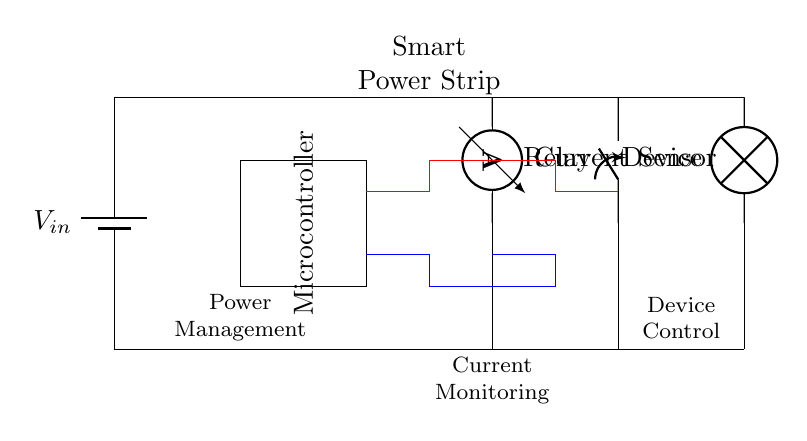What is the main function of the microcontroller? The microcontroller in the circuit is responsible for managing power and controlling the relay based on the inputs from the current sensor, which allows it to reduce standby power consumption when the devices are not in use.
Answer: Power management What type of sensor is used in this circuit? The current sensor is specifically designed to measure the current flowing to the connected device, providing data to the microcontroller for decision-making regarding power control.
Answer: Current sensor How many major components are shown in the circuit? By counting the distinct components in the diagram, we can identify five major components: a battery, a microcontroller, a current sensor, a relay, and a load/device.
Answer: Five What is the role of the relay in this circuit? The relay acts as a switch that opens or closes the connection to the load/device based on the control signals received from the microcontroller, effectively turning the device on or off to save energy.
Answer: Device control What connects the microcontroller to the current sensor? The microcontroller is connected to the current sensor by two wires; one for the signal input and another for ground, allowing it to receive current readings to decide on relay activation.
Answer: Two wires Which component is directly controlling the load? The relay is responsible for directly controlling the load, as it physically makes and breaks the connection dependent on the microcontroller's commands.
Answer: Relay 